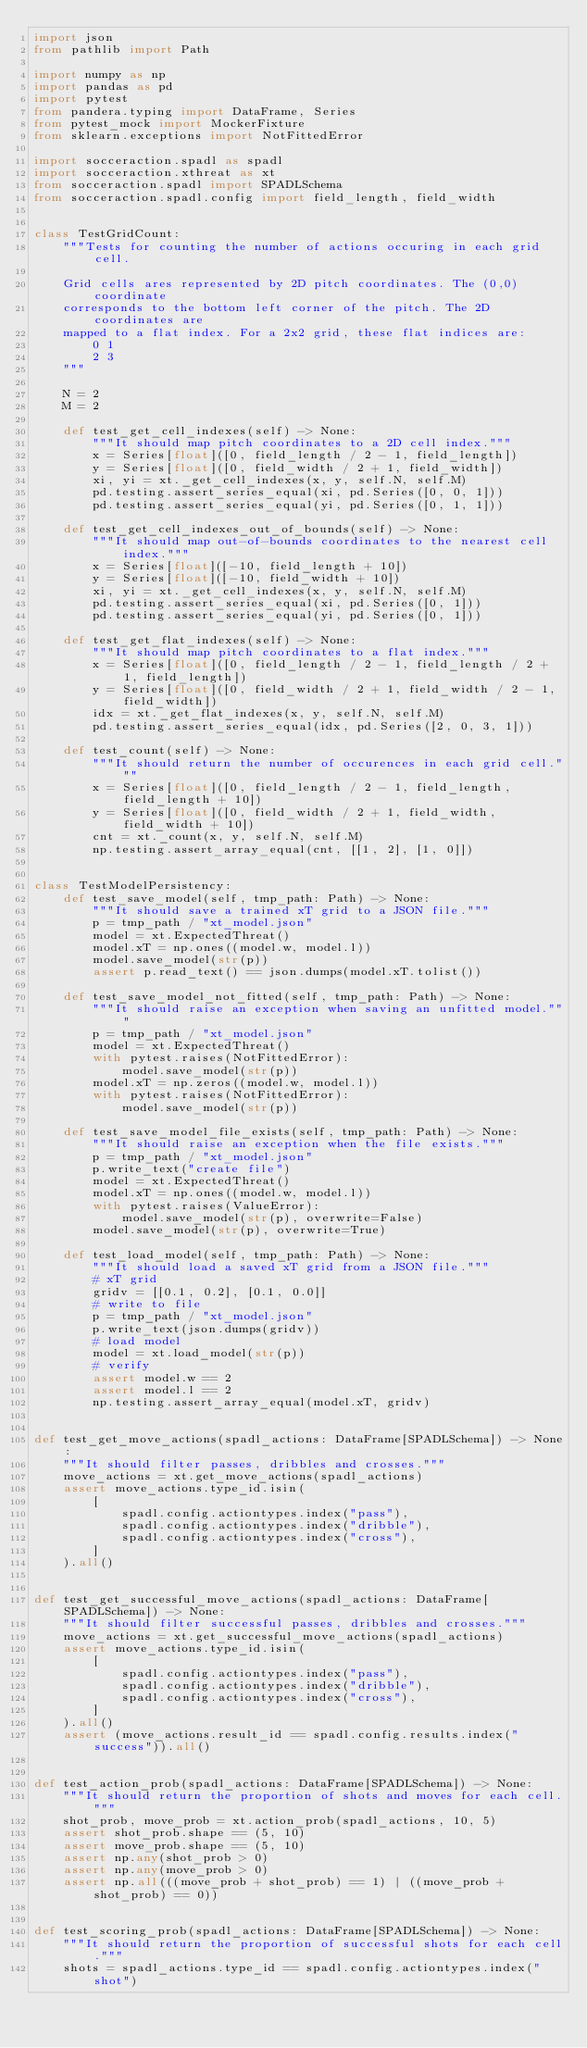<code> <loc_0><loc_0><loc_500><loc_500><_Python_>import json
from pathlib import Path

import numpy as np
import pandas as pd
import pytest
from pandera.typing import DataFrame, Series
from pytest_mock import MockerFixture
from sklearn.exceptions import NotFittedError

import socceraction.spadl as spadl
import socceraction.xthreat as xt
from socceraction.spadl import SPADLSchema
from socceraction.spadl.config import field_length, field_width


class TestGridCount:
    """Tests for counting the number of actions occuring in each grid cell.

    Grid cells ares represented by 2D pitch coordinates. The (0,0) coordinate
    corresponds to the bottom left corner of the pitch. The 2D coordinates are
    mapped to a flat index. For a 2x2 grid, these flat indices are:
        0 1
        2 3
    """

    N = 2
    M = 2

    def test_get_cell_indexes(self) -> None:
        """It should map pitch coordinates to a 2D cell index."""
        x = Series[float]([0, field_length / 2 - 1, field_length])
        y = Series[float]([0, field_width / 2 + 1, field_width])
        xi, yi = xt._get_cell_indexes(x, y, self.N, self.M)
        pd.testing.assert_series_equal(xi, pd.Series([0, 0, 1]))
        pd.testing.assert_series_equal(yi, pd.Series([0, 1, 1]))

    def test_get_cell_indexes_out_of_bounds(self) -> None:
        """It should map out-of-bounds coordinates to the nearest cell index."""
        x = Series[float]([-10, field_length + 10])
        y = Series[float]([-10, field_width + 10])
        xi, yi = xt._get_cell_indexes(x, y, self.N, self.M)
        pd.testing.assert_series_equal(xi, pd.Series([0, 1]))
        pd.testing.assert_series_equal(yi, pd.Series([0, 1]))

    def test_get_flat_indexes(self) -> None:
        """It should map pitch coordinates to a flat index."""
        x = Series[float]([0, field_length / 2 - 1, field_length / 2 + 1, field_length])
        y = Series[float]([0, field_width / 2 + 1, field_width / 2 - 1, field_width])
        idx = xt._get_flat_indexes(x, y, self.N, self.M)
        pd.testing.assert_series_equal(idx, pd.Series([2, 0, 3, 1]))

    def test_count(self) -> None:
        """It should return the number of occurences in each grid cell."""
        x = Series[float]([0, field_length / 2 - 1, field_length, field_length + 10])
        y = Series[float]([0, field_width / 2 + 1, field_width, field_width + 10])
        cnt = xt._count(x, y, self.N, self.M)
        np.testing.assert_array_equal(cnt, [[1, 2], [1, 0]])


class TestModelPersistency:
    def test_save_model(self, tmp_path: Path) -> None:
        """It should save a trained xT grid to a JSON file."""
        p = tmp_path / "xt_model.json"
        model = xt.ExpectedThreat()
        model.xT = np.ones((model.w, model.l))
        model.save_model(str(p))
        assert p.read_text() == json.dumps(model.xT.tolist())

    def test_save_model_not_fitted(self, tmp_path: Path) -> None:
        """It should raise an exception when saving an unfitted model."""
        p = tmp_path / "xt_model.json"
        model = xt.ExpectedThreat()
        with pytest.raises(NotFittedError):
            model.save_model(str(p))
        model.xT = np.zeros((model.w, model.l))
        with pytest.raises(NotFittedError):
            model.save_model(str(p))

    def test_save_model_file_exists(self, tmp_path: Path) -> None:
        """It should raise an exception when the file exists."""
        p = tmp_path / "xt_model.json"
        p.write_text("create file")
        model = xt.ExpectedThreat()
        model.xT = np.ones((model.w, model.l))
        with pytest.raises(ValueError):
            model.save_model(str(p), overwrite=False)
        model.save_model(str(p), overwrite=True)

    def test_load_model(self, tmp_path: Path) -> None:
        """It should load a saved xT grid from a JSON file."""
        # xT grid
        gridv = [[0.1, 0.2], [0.1, 0.0]]
        # write to file
        p = tmp_path / "xt_model.json"
        p.write_text(json.dumps(gridv))
        # load model
        model = xt.load_model(str(p))
        # verify
        assert model.w == 2
        assert model.l == 2
        np.testing.assert_array_equal(model.xT, gridv)


def test_get_move_actions(spadl_actions: DataFrame[SPADLSchema]) -> None:
    """It should filter passes, dribbles and crosses."""
    move_actions = xt.get_move_actions(spadl_actions)
    assert move_actions.type_id.isin(
        [
            spadl.config.actiontypes.index("pass"),
            spadl.config.actiontypes.index("dribble"),
            spadl.config.actiontypes.index("cross"),
        ]
    ).all()


def test_get_successful_move_actions(spadl_actions: DataFrame[SPADLSchema]) -> None:
    """It should filter successful passes, dribbles and crosses."""
    move_actions = xt.get_successful_move_actions(spadl_actions)
    assert move_actions.type_id.isin(
        [
            spadl.config.actiontypes.index("pass"),
            spadl.config.actiontypes.index("dribble"),
            spadl.config.actiontypes.index("cross"),
        ]
    ).all()
    assert (move_actions.result_id == spadl.config.results.index("success")).all()


def test_action_prob(spadl_actions: DataFrame[SPADLSchema]) -> None:
    """It should return the proportion of shots and moves for each cell."""
    shot_prob, move_prob = xt.action_prob(spadl_actions, 10, 5)
    assert shot_prob.shape == (5, 10)
    assert move_prob.shape == (5, 10)
    assert np.any(shot_prob > 0)
    assert np.any(move_prob > 0)
    assert np.all(((move_prob + shot_prob) == 1) | ((move_prob + shot_prob) == 0))


def test_scoring_prob(spadl_actions: DataFrame[SPADLSchema]) -> None:
    """It should return the proportion of successful shots for each cell."""
    shots = spadl_actions.type_id == spadl.config.actiontypes.index("shot")</code> 